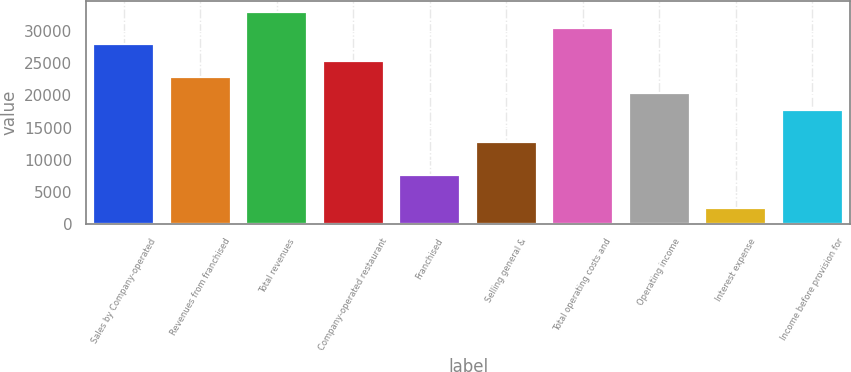Convert chart to OTSL. <chart><loc_0><loc_0><loc_500><loc_500><bar_chart><fcel>Sales by Company-operated<fcel>Revenues from franchised<fcel>Total revenues<fcel>Company-operated restaurant<fcel>Franchised<fcel>Selling general &<fcel>Total operating costs and<fcel>Operating income<fcel>Interest expense<fcel>Income before provision for<nl><fcel>27953.8<fcel>22872.2<fcel>33035.5<fcel>25413<fcel>7627.26<fcel>12708.9<fcel>30494.6<fcel>20331.4<fcel>2545.62<fcel>17790.5<nl></chart> 